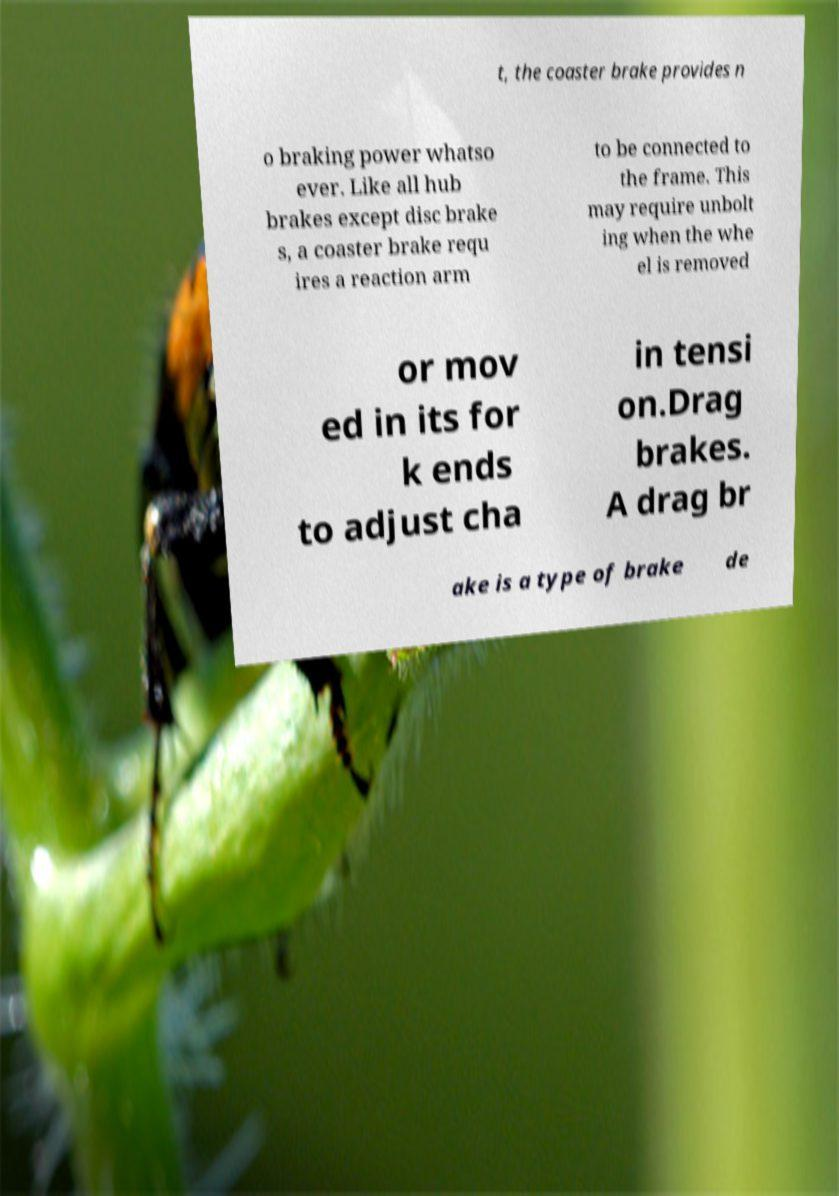Please identify and transcribe the text found in this image. t, the coaster brake provides n o braking power whatso ever. Like all hub brakes except disc brake s, a coaster brake requ ires a reaction arm to be connected to the frame. This may require unbolt ing when the whe el is removed or mov ed in its for k ends to adjust cha in tensi on.Drag brakes. A drag br ake is a type of brake de 